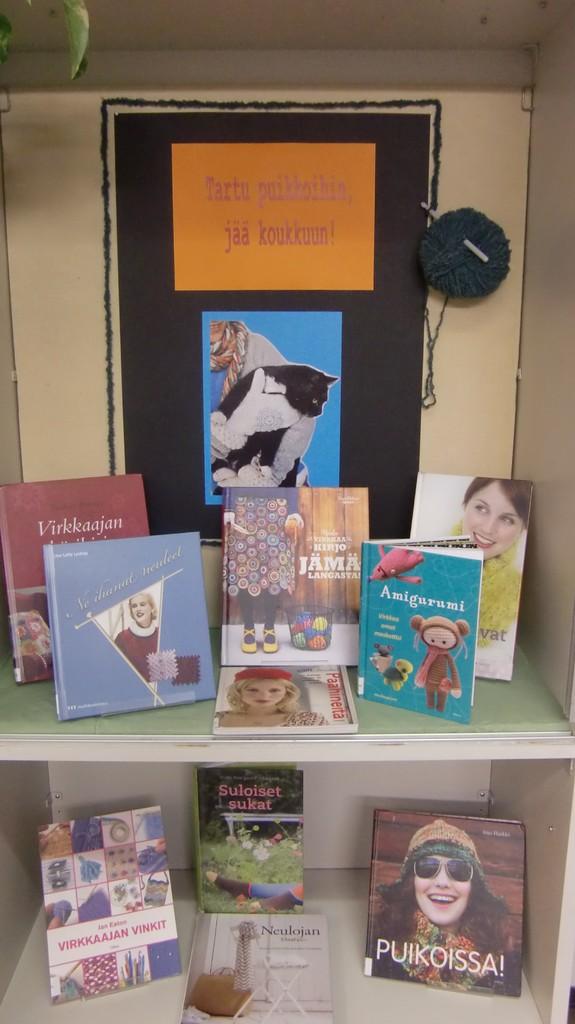What is the title of the bottom right book?
Offer a very short reply. Puikoissa. 